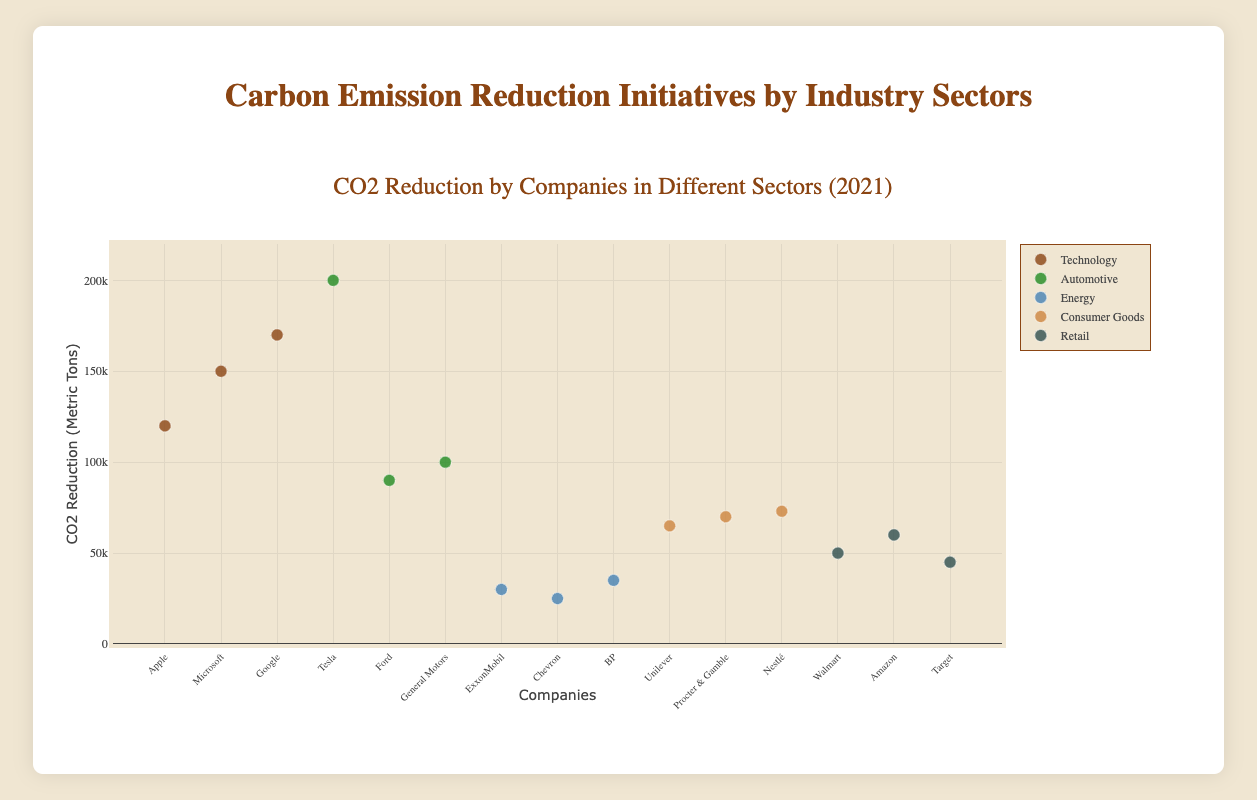Which sector has the highest CO2 reduction for a single company? The Automotive sector has the highest single-company CO2 reduction, with Tesla reducing 200,000 metric tons of CO2.
Answer: Automotive What is the total CO2 reduction by companies in the Technology sector? Summing up CO2 reductions by Apple (120,000), Microsoft (150,000), and Google (170,000), we get 120,000 + 150,000 + 170,000 = 440,000 metric tons.
Answer: 440,000 metric tons How does Apple's CO2 reduction compare to Tesla's? Apple's CO2 reduction is 120,000 metric tons, while Tesla's is 200,000 metric tons. Tesla's reduction is greater by 80,000 metric tons.
Answer: Tesla's is greater by 80,000 metric tons Which sector has the lowest total CO2 reduction, and how much is it? Summing up the reductions in each sector, the Energy sector has the lowest total: ExxonMobil (30,000) + Chevron (25,000) + BP (35,000) = 90,000 metric tons.
Answer: Energy, 90,000 metric tons What is the average CO2 reduction among all companies in the Retail sector? Adding Walmart (50,000), Amazon (60,000), and Target (45,000) gives 50,000 + 60,000 + 45,000 = 155,000. The average is 155,000 / 3 ≈ 51,667 metric tons.
Answer: 51,667 metric tons Which company in the Consumer Goods sector has the highest CO2 reduction? Among Unilever (65,000), Procter & Gamble (70,000), and Nestlé (73,000), Nestlé has the highest CO2 reduction at 73,000 metric tons.
Answer: Nestlé Is the CO2 reduction by Microsoft greater than the combined reduction of BP and ExxonMobil? Combined reduction for BP (35,000) and ExxonMobil (30,000) is 35,000 + 30,000 = 65,000, which is less than Microsoft's reduction of 150,000 metric tons.
Answer: Yes Which company has the second-largest CO2 reduction in the Automotive sector? In the Automotive sector, Tesla's reduction is 200,000, followed by General Motors with 100,000 metric tons. Ford has the third-largest reduction at 90,000 metric tons.
Answer: General Motors 